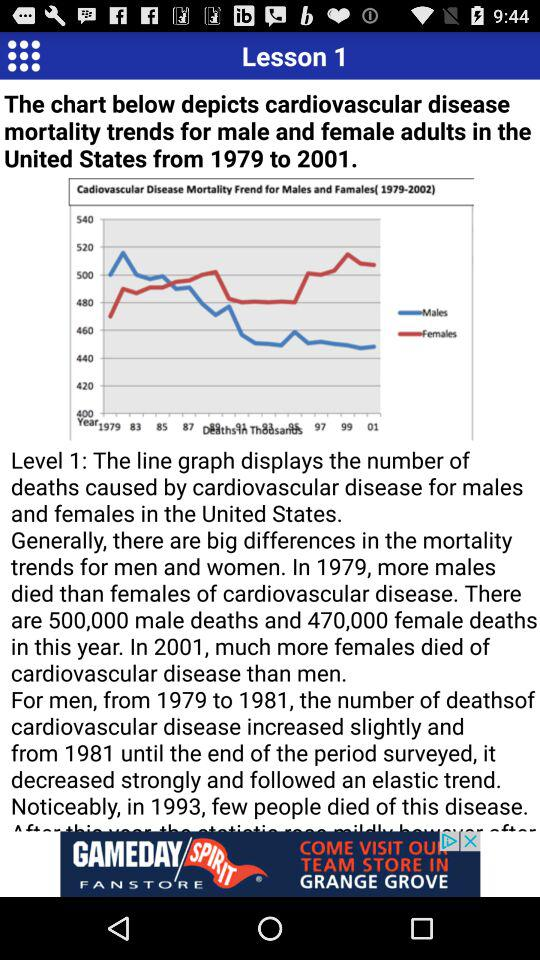How many males died? The males who died were 500,000. 